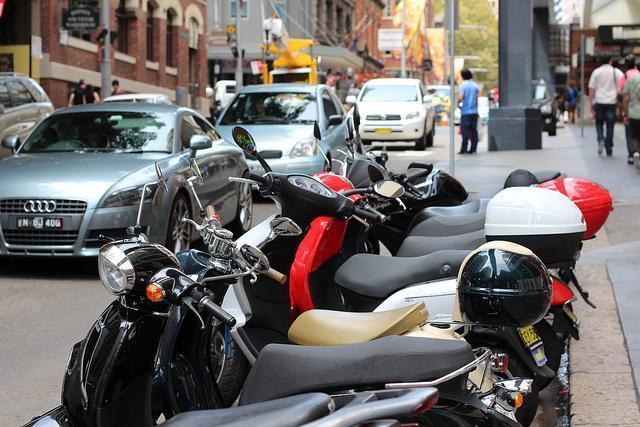How many cars can you see?
Give a very brief answer. 4. How many motorcycles are in the photo?
Give a very brief answer. 7. How many toothbrushes are here?
Give a very brief answer. 0. 